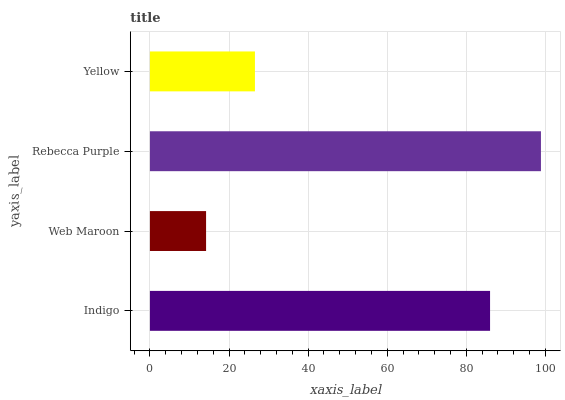Is Web Maroon the minimum?
Answer yes or no. Yes. Is Rebecca Purple the maximum?
Answer yes or no. Yes. Is Rebecca Purple the minimum?
Answer yes or no. No. Is Web Maroon the maximum?
Answer yes or no. No. Is Rebecca Purple greater than Web Maroon?
Answer yes or no. Yes. Is Web Maroon less than Rebecca Purple?
Answer yes or no. Yes. Is Web Maroon greater than Rebecca Purple?
Answer yes or no. No. Is Rebecca Purple less than Web Maroon?
Answer yes or no. No. Is Indigo the high median?
Answer yes or no. Yes. Is Yellow the low median?
Answer yes or no. Yes. Is Rebecca Purple the high median?
Answer yes or no. No. Is Rebecca Purple the low median?
Answer yes or no. No. 